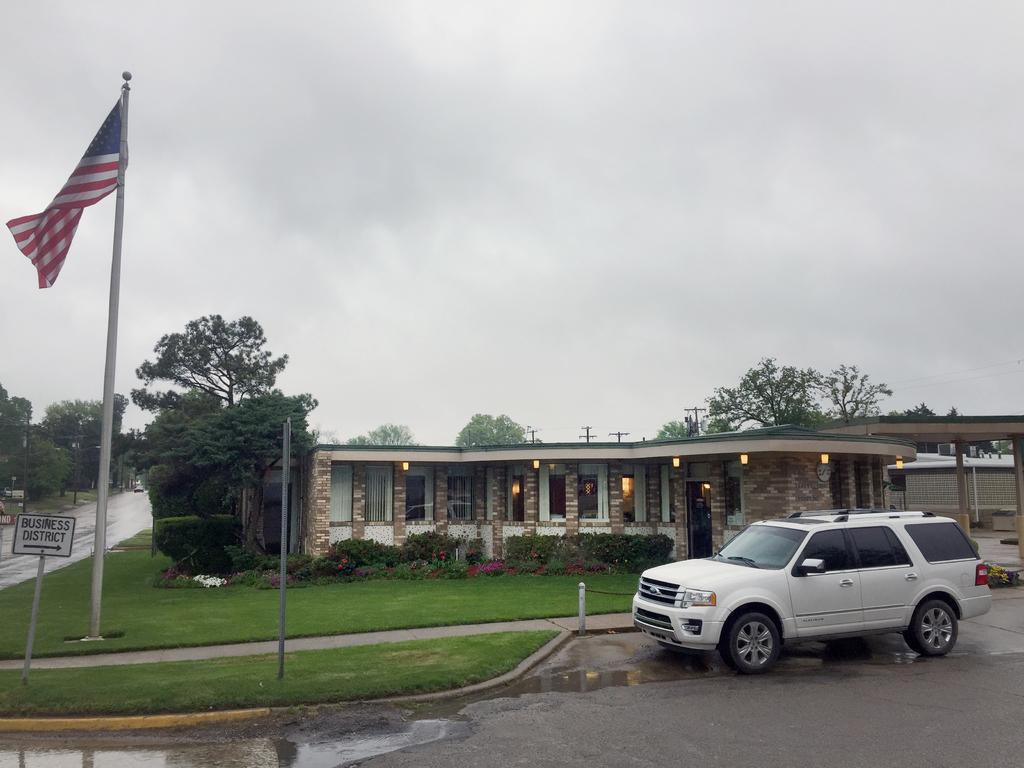In one or two sentences, can you explain what this image depicts? In the foreground of this image, there is a car on the road, a flag and sign boards on the grass. In the background, there is a building, plants, trees, poles, a road and the sky. 